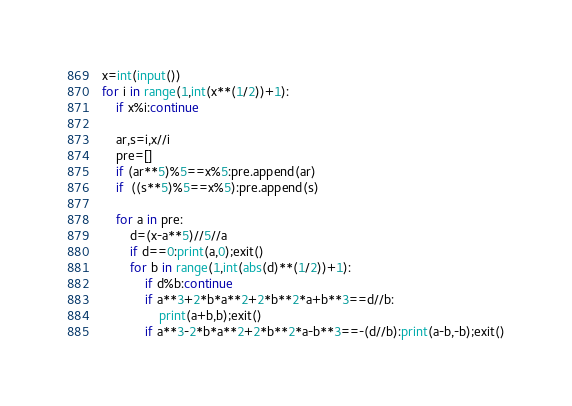Convert code to text. <code><loc_0><loc_0><loc_500><loc_500><_Python_>x=int(input())
for i in range(1,int(x**(1/2))+1):
    if x%i:continue

    ar,s=i,x//i
    pre=[]
    if (ar**5)%5==x%5:pre.append(ar)
    if  ((s**5)%5==x%5):pre.append(s)

    for a in pre:
        d=(x-a**5)//5//a
        if d==0:print(a,0);exit()
        for b in range(1,int(abs(d)**(1/2))+1):
            if d%b:continue
            if a**3+2*b*a**2+2*b**2*a+b**3==d//b:
                print(a+b,b);exit()
            if a**3-2*b*a**2+2*b**2*a-b**3==-(d//b):print(a-b,-b);exit()
</code> 